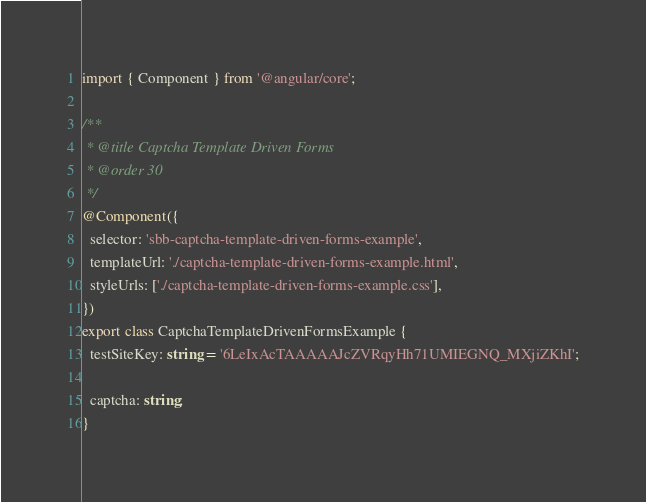<code> <loc_0><loc_0><loc_500><loc_500><_TypeScript_>import { Component } from '@angular/core';

/**
 * @title Captcha Template Driven Forms
 * @order 30
 */
@Component({
  selector: 'sbb-captcha-template-driven-forms-example',
  templateUrl: './captcha-template-driven-forms-example.html',
  styleUrls: ['./captcha-template-driven-forms-example.css'],
})
export class CaptchaTemplateDrivenFormsExample {
  testSiteKey: string = '6LeIxAcTAAAAAJcZVRqyHh71UMIEGNQ_MXjiZKhI';

  captcha: string;
}
</code> 